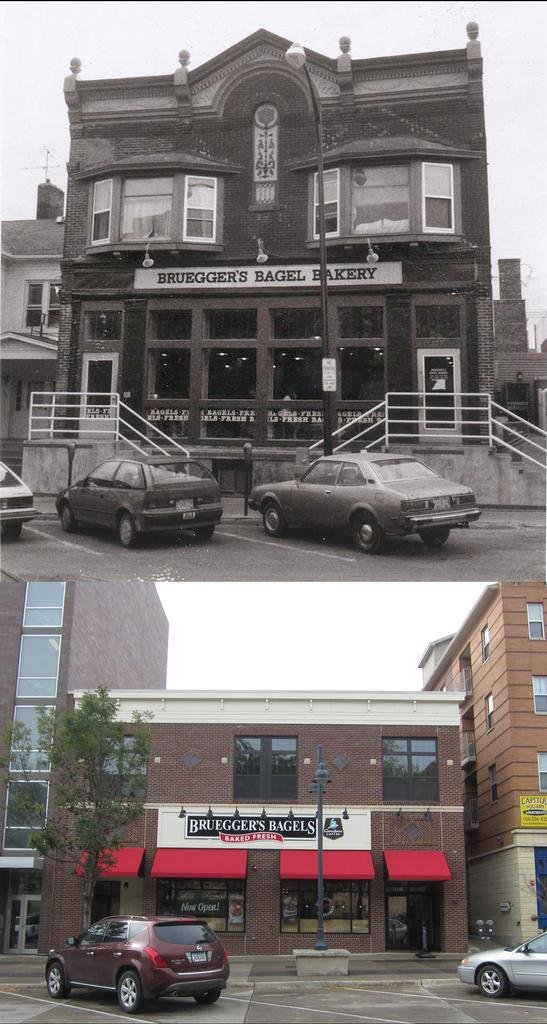What is the composition of the image? The image is a collage of two images. What can be seen in both images? Both images contain buildings. What else is present in the images? Cars are present in front of the buildings. What type of jam is being spread on the worm in the image? There is no jam or worm present in the image; it contains only buildings and cars. 